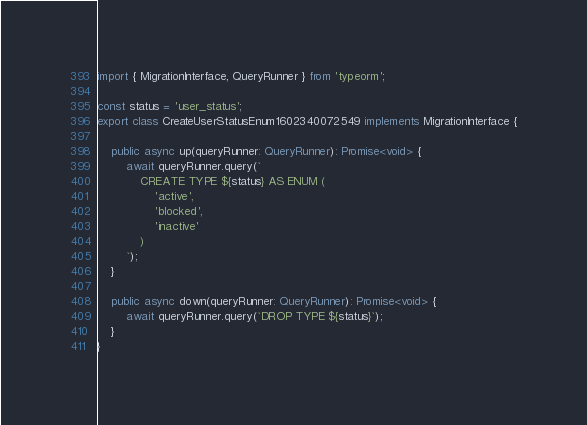Convert code to text. <code><loc_0><loc_0><loc_500><loc_500><_TypeScript_>import { MigrationInterface, QueryRunner } from 'typeorm';

const status = 'user_status';
export class CreateUserStatusEnum1602340072549 implements MigrationInterface {

    public async up(queryRunner: QueryRunner): Promise<void> {
        await queryRunner.query(`
            CREATE TYPE ${status} AS ENUM (
                'active',
                'blocked',
                'inactive'
            )
        `);
    }

    public async down(queryRunner: QueryRunner): Promise<void> {
        await queryRunner.query(`DROP TYPE ${status}`);
    }
}
</code> 